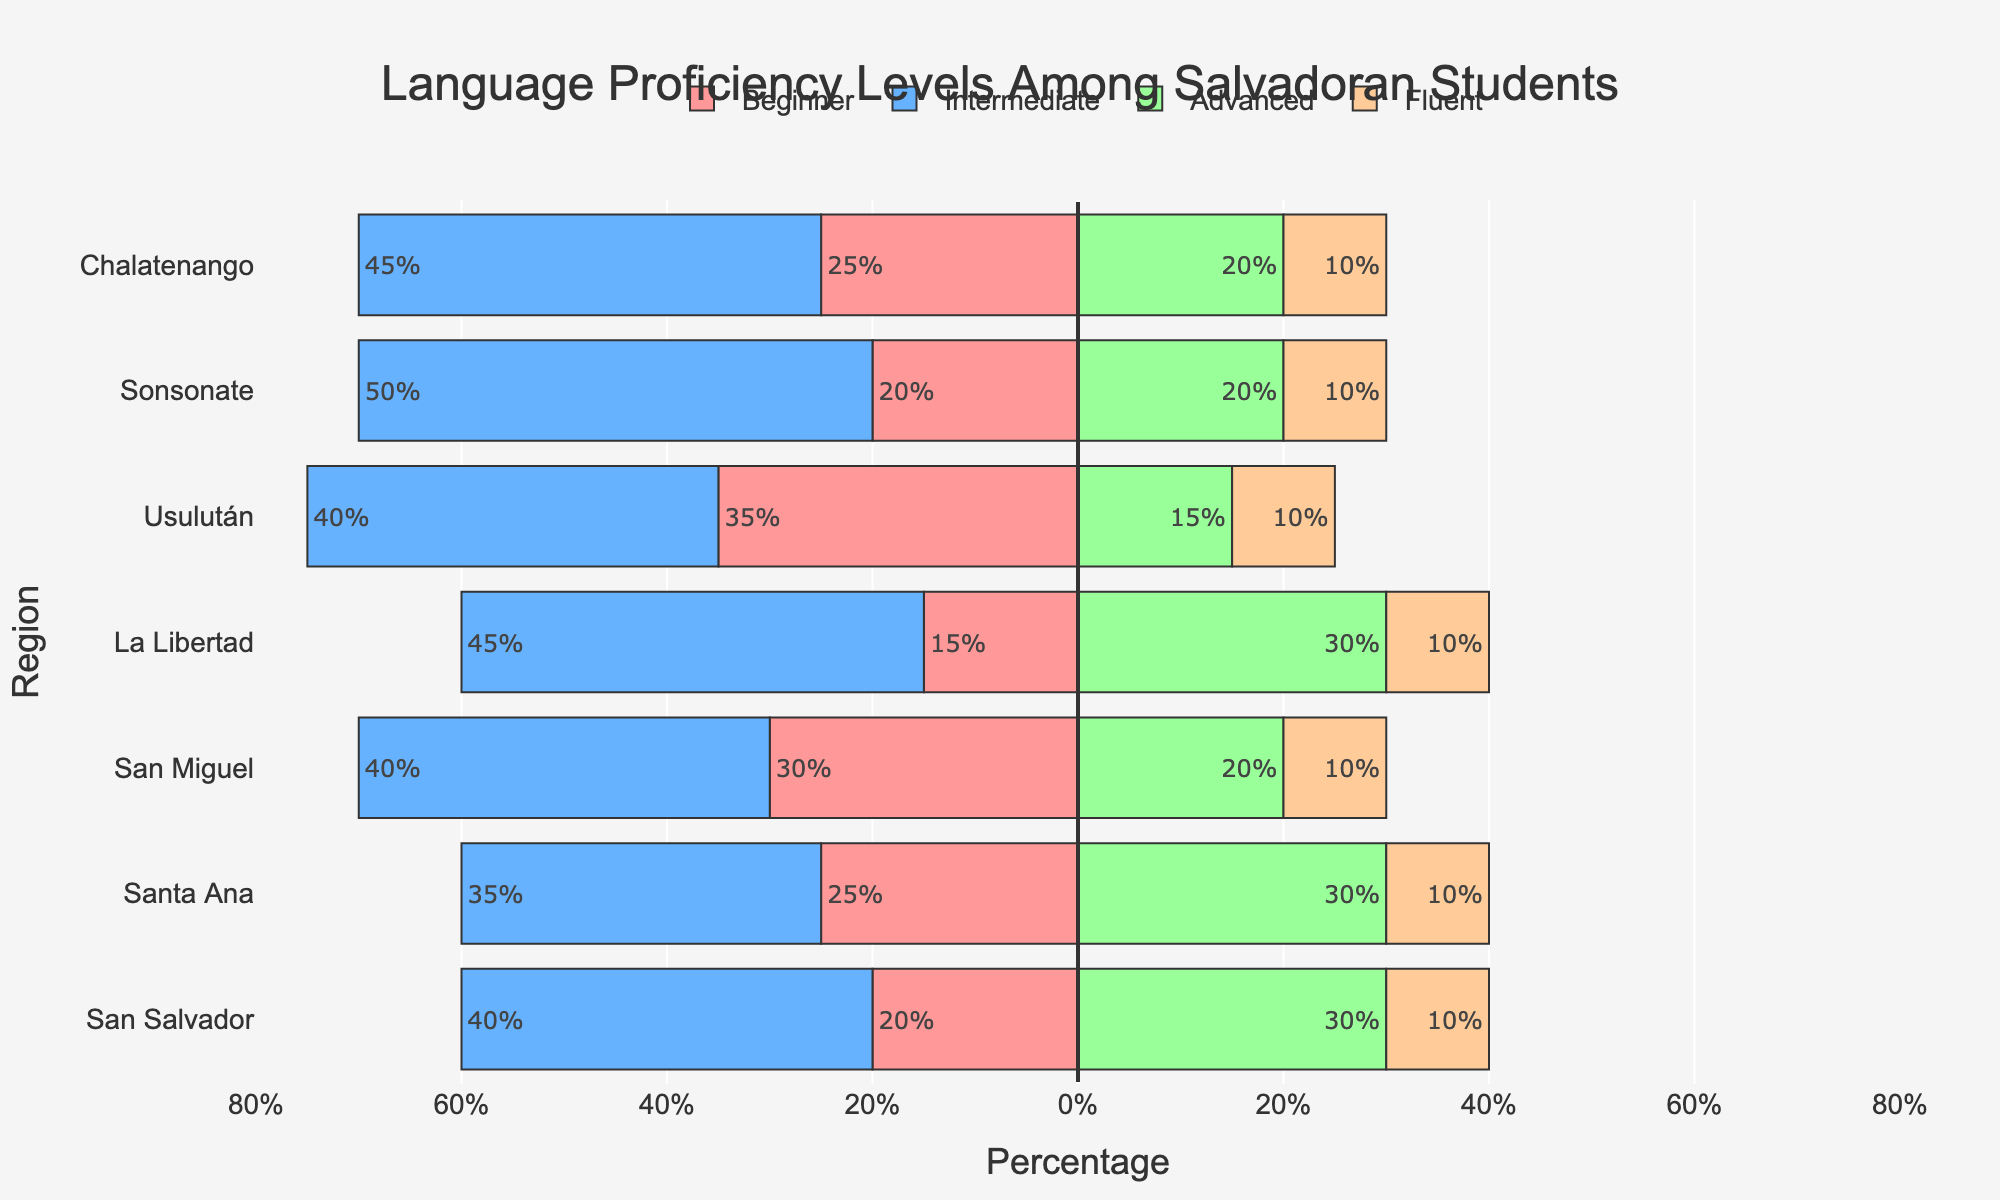Which region has the highest percentage of students at the intermediate level? The bar corresponding to the intermediate proficiency level has the longest positive projection, indicating the highest percentage of students in this category. In Usulután, the length stretches further than any other region in the positive direction.
Answer: Usulután Which region has the lowest percentage of beginner-level students? The bar corresponding to the beginner proficiency level has the shortest negative projection. In La Libertad, the length of the negative side is considerably smaller compared to the other regions.
Answer: La Libertad What is the total percentage of students at the advanced and fluent levels in San Salvador? Adding the percentages of the advanced and fluent levels in San Salvador: 30% (advanced) + 10% (fluent) = 40%.
Answer: 40% How much greater is the percentage of intermediate-level students in Sonsonate compared to advanced-level students in San Salvador? Compare the intermediate percentage in Sonsonate (50%) to the advanced percentage in San Salvador (30%): 50% - 30% = 20%.
Answer: 20% Which region has the most balanced distribution of proficiency levels? Looking for the region where the lengths of the bars across all proficiency levels are more similar, Santa Ana has relatively balanced lengths across beginner, intermediate, advanced, and fluent levels.
Answer: Santa Ana In which region is the disparity between beginner and advanced students largest? By calculating the absolute differences between the beginner and advanced percentages for each region, Usulután has the largest disparity: 35% (beginner) - 15% (advanced) = 20%.
Answer: Usulután What is the sum of the percentage of students at the fluent level across all regions? Sum the fluent-level percentages: 10% (San Salvador) + 10% (Santa Ana) + 10% (San Miguel) + 10% (La Libertad) + 10% (Usulután) + 10% (Sonsonate) + 10% (Chalatenango) = 70%.
Answer: 70% How does the percentage of beginner-level students in San Miguel compare to La Libertad? Compare the beginner percentages: San Miguel has 30%, and La Libertad has 15%. 30% - 15% = 15% greater in San Miguel.
Answer: 15% greater in San Miguel Among the regions, which one has the highest combined percentage of intermediate and advanced students? Adding the intermediate and advanced percentages for each region shows that Sonsonate has the highest combined value: 50% (intermediate) + 20% (advanced) = 70%.
Answer: Sonsonate Which region exhibits the smallest gap between intermediate and advanced proficiency levels? Calculate the differences between intermediate and advanced percentages for each region; the smallest gap is found in San Salvador: 40% (intermediate) - 30% (advanced) = 10%.
Answer: San Salvador 